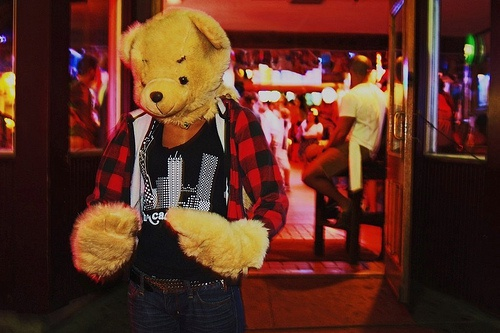Describe the objects in this image and their specific colors. I can see people in black, orange, maroon, and tan tones, teddy bear in black, orange, olive, and tan tones, people in black, maroon, tan, and brown tones, chair in black, maroon, brown, and salmon tones, and people in black, brown, maroon, and lightpink tones in this image. 